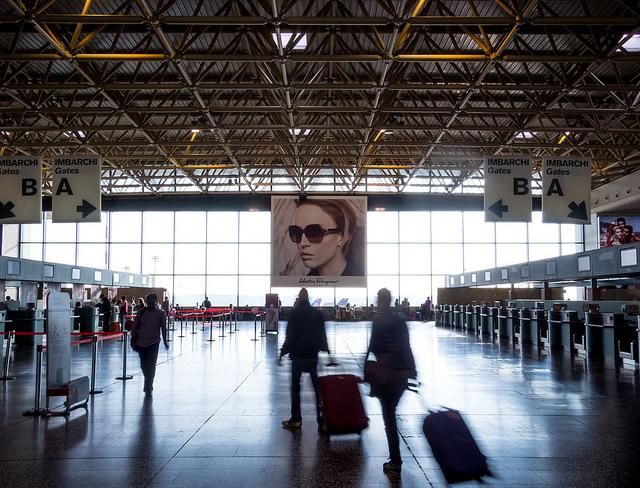Does the visible luggage have wheels?
Short answer required. Yes. What could this place be?
Short answer required. Airport. Is the woman in the picture wearing sunglasses?
Give a very brief answer. Yes. 